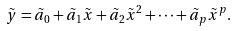Convert formula to latex. <formula><loc_0><loc_0><loc_500><loc_500>\tilde { y } = \tilde { a } _ { 0 } + \tilde { a } _ { 1 } \tilde { x } + \tilde { a } _ { 2 } \tilde { x } ^ { 2 } + \cdots + \tilde { a } _ { p } \tilde { x } ^ { p } .</formula> 